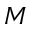<formula> <loc_0><loc_0><loc_500><loc_500>M</formula> 